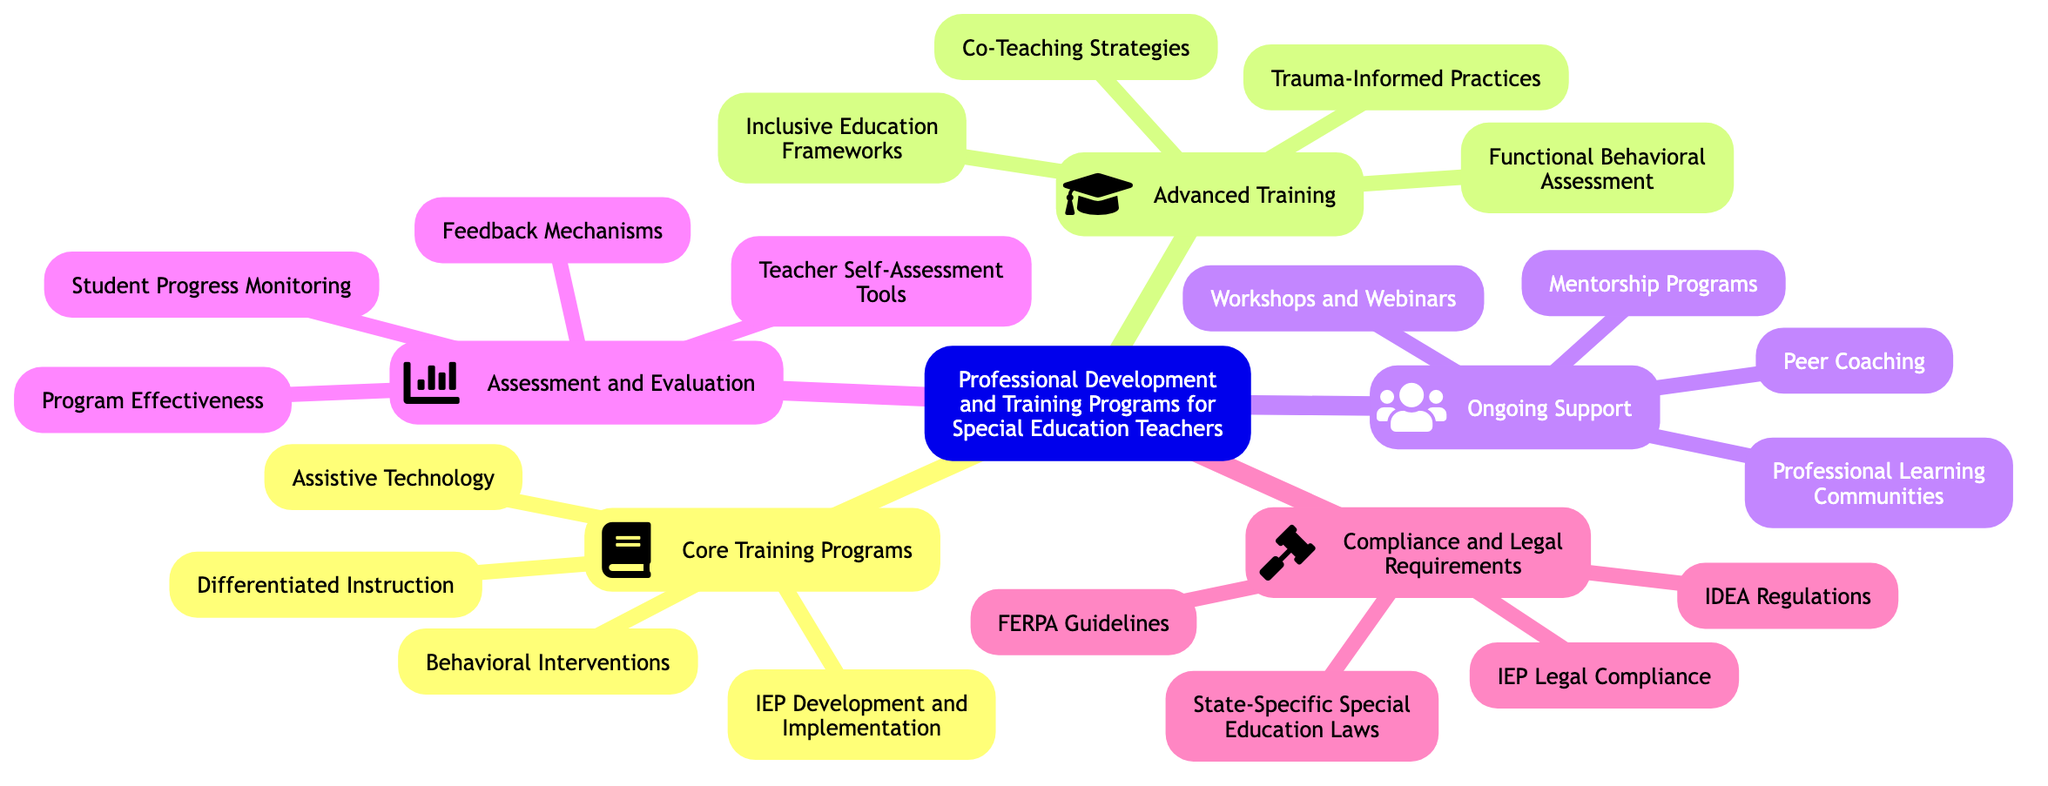What are the sub-topics under the main topic? The main topic is "Professional Development and Training Programs for Special Education Teachers." The sub-topics listed below it include "Core Training Programs," "Advanced Training," "Ongoing Support," "Assessment and Evaluation," and "Compliance and Legal Requirements."
Answer: Core Training Programs, Advanced Training, Ongoing Support, Assessment and Evaluation, Compliance and Legal Requirements How many elements are in the "Core Training Programs" section? In the "Core Training Programs" section, there are four elements listed: "IEP Development and Implementation," "Behavioral Interventions," "Differentiated Instruction," and "Assistive Technology." Counting each element gives a total of four.
Answer: 4 What advanced training topic relates to inclusive education? The topic that specifically relates to inclusive education in the "Advanced Training" section is "Inclusive Education Frameworks." This can be identified as it is explicitly stated within that sub-topic.
Answer: Inclusive Education Frameworks Which training type includes mentorship programs? The "Ongoing Support" sub-topic includes "Mentorship Programs." This can be found as an element listed directly under the "Ongoing Support" section of the diagram.
Answer: Ongoing Support What is the total number of elements across all sub-topics in the diagram? To find the total number of elements, count the elements in each sub-topic: 4 in "Core Training Programs," 4 in "Advanced Training," 4 in "Ongoing Support," 4 in "Assessment and Evaluation," and 4 in "Compliance and Legal Requirements." The total equals 20.
Answer: 20 Which compliance requirement pertains to regulations? The compliance requirement that pertains to regulations is "IDEA Regulations." This is directly listed under the "Compliance and Legal Requirements" sub-topic.
Answer: IDEA Regulations How many ongoing support elements are there? In the "Ongoing Support" section, there are four listed elements: "Mentorship Programs," "Peer Coaching," "Professional Learning Communities," and "Workshops and Webinars." Therefore, the number of ongoing support elements is four.
Answer: 4 Identify one element related to student evaluation. The element related to student evaluation is "Student Progress Monitoring," which is found in the "Assessment and Evaluation" sub-topic. This can be recognized as it is one of the listed elements under that category.
Answer: Student Progress Monitoring Which sub-topic covers legal compliance related to IEPs? The sub-topic that covers legal compliance related to IEPs is "Compliance and Legal Requirements." "IEP Legal Compliance" is explicitly listed as one of the elements under this sub-topic.
Answer: Compliance and Legal Requirements What element in the advanced training section involves trauma? The element in the advanced training section that involves trauma is "Trauma-Informed Practices." This is clearly labeled as one of the topics in the "Advanced Training" category of the diagram.
Answer: Trauma-Informed Practices 